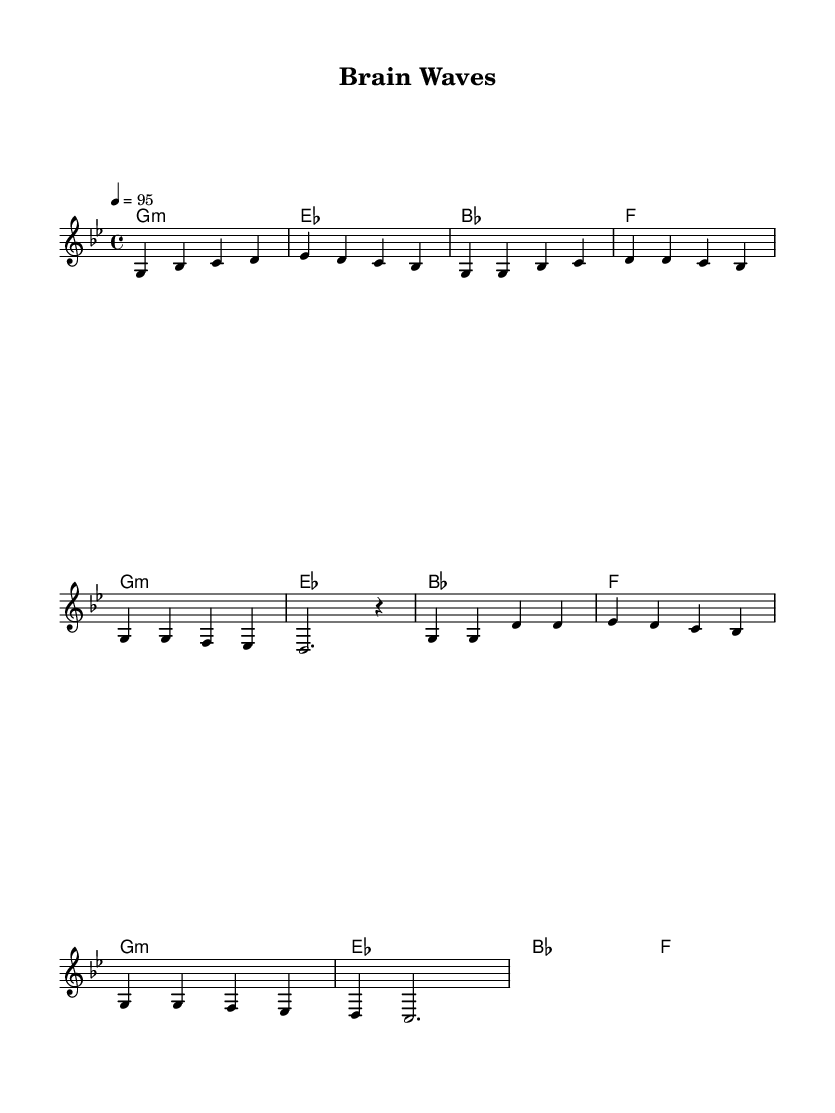What is the key signature of this music? The key signature is G minor, which has two flats (B♭ and E♭). This can be determined from the key signature indicated at the beginning of the sheet music.
Answer: G minor What is the time signature of this music? The time signature is 4/4, as indicated near the beginning of the score. This shows that there are four beats in each measure, with the quarter note receiving one beat.
Answer: 4/4 What is the tempo marking for this piece? The tempo marking is 4 = 95, which indicates the metronome beats per minute. It shows that there are 95 beats per minute, aligning with a moderate pace suitable for an upbeat anthem.
Answer: 95 What is the total number of measures in the melody section? The melody section consists of 8 measures, counted by observing the vertical lines (bars) that separate each measure in the score.
Answer: 8 What is the main chord used in the chorus section? The main chord used in the chorus is G minor, which appears at the start of the chorus and reoccurs multiple times, emphasizing its importance in this section.
Answer: G minor How do the harmonies in the verses compare to the harmonies in the chorus? The harmonies in both the verses and the chorus are the same chord progression, featuring G minor, E♭, B♭, and F, contributing to a cohesive musical structure throughout the piece.
Answer: Same What genre does this piece belong to? This piece belongs to the hip-hop genre, as indicated by the title and the upbeat, celebratory nature of the anthem, focusing on neurological breakthroughs reflective of themes often found in hip-hop music.
Answer: Hip-hop 